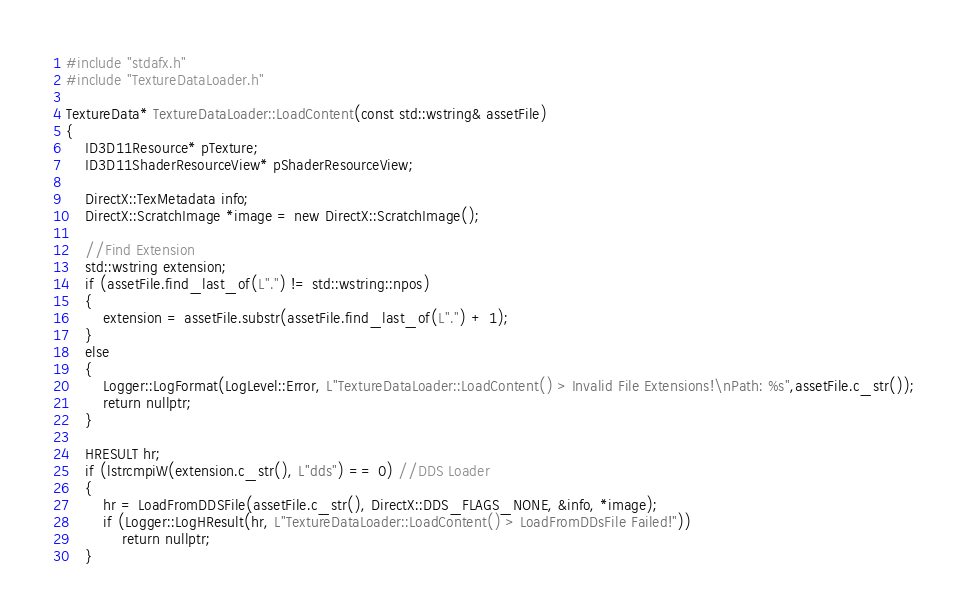Convert code to text. <code><loc_0><loc_0><loc_500><loc_500><_C++_>#include "stdafx.h"
#include "TextureDataLoader.h"

TextureData* TextureDataLoader::LoadContent(const std::wstring& assetFile)
{
	ID3D11Resource* pTexture;
	ID3D11ShaderResourceView* pShaderResourceView;

	DirectX::TexMetadata info;
	DirectX::ScratchImage *image = new DirectX::ScratchImage();

	//Find Extension
	std::wstring extension;
	if (assetFile.find_last_of(L".") != std::wstring::npos)
	{
		extension = assetFile.substr(assetFile.find_last_of(L".") + 1);
	}
	else
	{
		Logger::LogFormat(LogLevel::Error, L"TextureDataLoader::LoadContent() > Invalid File Extensions!\nPath: %s",assetFile.c_str());
		return nullptr;
	}
		
	HRESULT hr;
	if (lstrcmpiW(extension.c_str(), L"dds") == 0) //DDS Loader
	{
		hr = LoadFromDDSFile(assetFile.c_str(), DirectX::DDS_FLAGS_NONE, &info, *image);
		if (Logger::LogHResult(hr, L"TextureDataLoader::LoadContent() > LoadFromDDsFile Failed!"))
			return nullptr;
	}</code> 